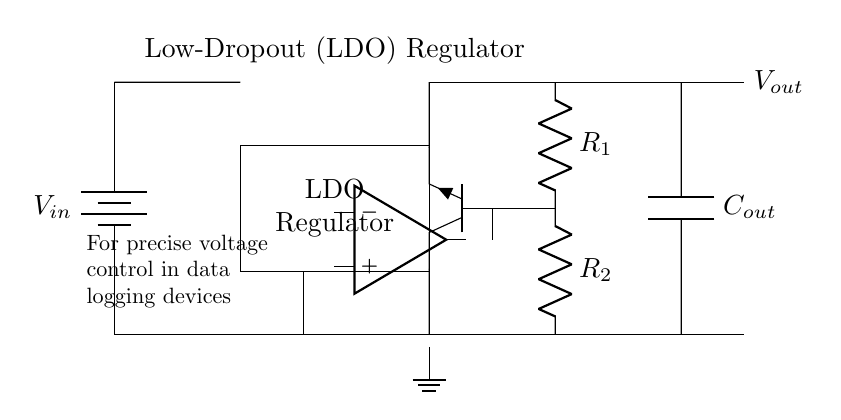What is the input component of this circuit? The input component is a battery labeled as "Vin," which provides the input voltage to the circuit. It is represented as a vertical line with the label indicating the voltage input.
Answer: battery What does the rectangle in the circuit represent? The rectangle in the circuit represents the Low-Dropout (LDO) regulator. This component is responsible for regulating the voltage output while maintaining a low voltage drop between input and output.
Answer: LDO Regulator What is the function of the feedback network in this circuit? The feedback network, consisting of resistors labeled R1 and R2, is used to sample the output voltage and feed it back to the error amplifier, allowing precise voltage control by adjusting the output based on the output feedback.
Answer: Voltage control How many resistors are present in the feedback network? There are two resistors in the feedback network, labeled R1 and R2, which are used to form a voltage divider for feedback purposes.
Answer: 2 What is the purpose of the capacitor labeled Cout in the output? The capacitor labeled Cout serves to filter the output of the regulator, smoothing out any voltage fluctuations and ensuring stable output voltage for connected devices, like data logging equipment.
Answer: Filter What type of transistor is used in the regulator circuit? The circuit uses a NPN transistor, labeled Q1. This type of transistor is commonly employed in LDO regulators to control the output current while maintaining low dropout voltage.
Answer: NPN What is the output voltage labeled in the circuit? The output voltage is indicated as "Vout," representing the controlled voltage that the LDO regulator supplies to the load or connected devices.
Answer: Vout 